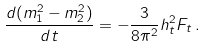<formula> <loc_0><loc_0><loc_500><loc_500>\frac { d ( m _ { 1 } ^ { 2 } - m _ { 2 } ^ { 2 } ) } { d t } = - \frac { 3 } { 8 \pi ^ { 2 } } h _ { t } ^ { 2 } F _ { t } \, .</formula> 